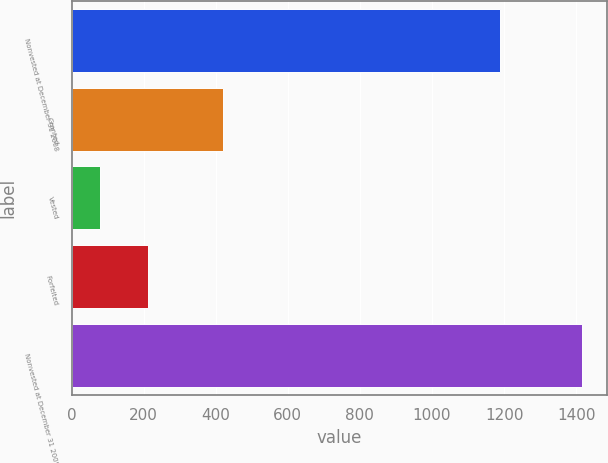<chart> <loc_0><loc_0><loc_500><loc_500><bar_chart><fcel>Nonvested at December 31 2008<fcel>Granted<fcel>Vested<fcel>Forfeited<fcel>Nonvested at December 31 2009<nl><fcel>1188<fcel>420<fcel>79<fcel>212.6<fcel>1415<nl></chart> 